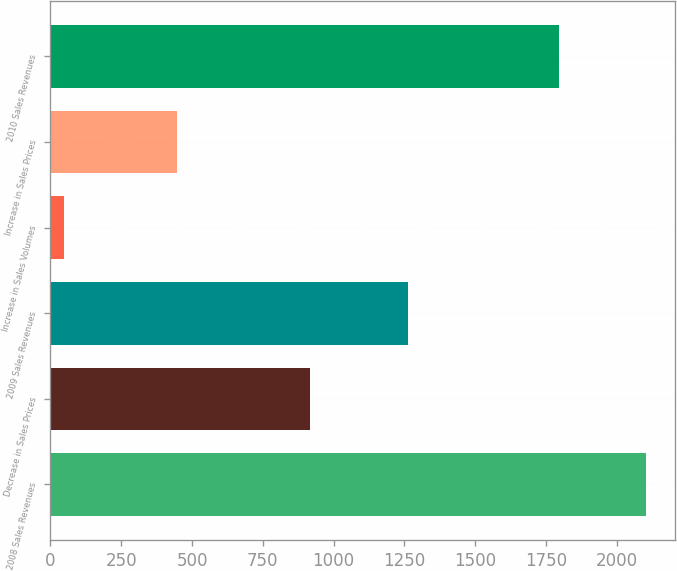Convert chart to OTSL. <chart><loc_0><loc_0><loc_500><loc_500><bar_chart><fcel>2008 Sales Revenues<fcel>Decrease in Sales Prices<fcel>2009 Sales Revenues<fcel>Increase in Sales Volumes<fcel>Increase in Sales Prices<fcel>2010 Sales Revenues<nl><fcel>2101<fcel>915<fcel>1261<fcel>48<fcel>447<fcel>1795<nl></chart> 